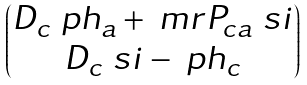<formula> <loc_0><loc_0><loc_500><loc_500>\begin{pmatrix} D _ { c } \ p h _ { a } + \ m r { P } _ { c a } \ s i \\ D _ { c } \ s i - \ p h _ { c } \end{pmatrix}</formula> 